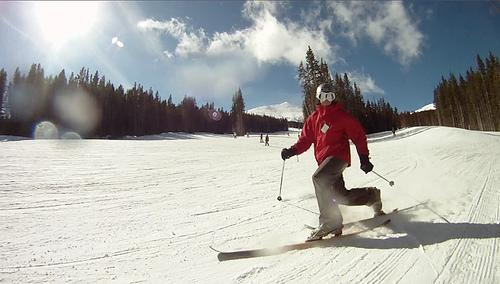What is causing the glare in the image?

Choices:
A) flashlights
B) street lights
C) sun
D) torches sun 